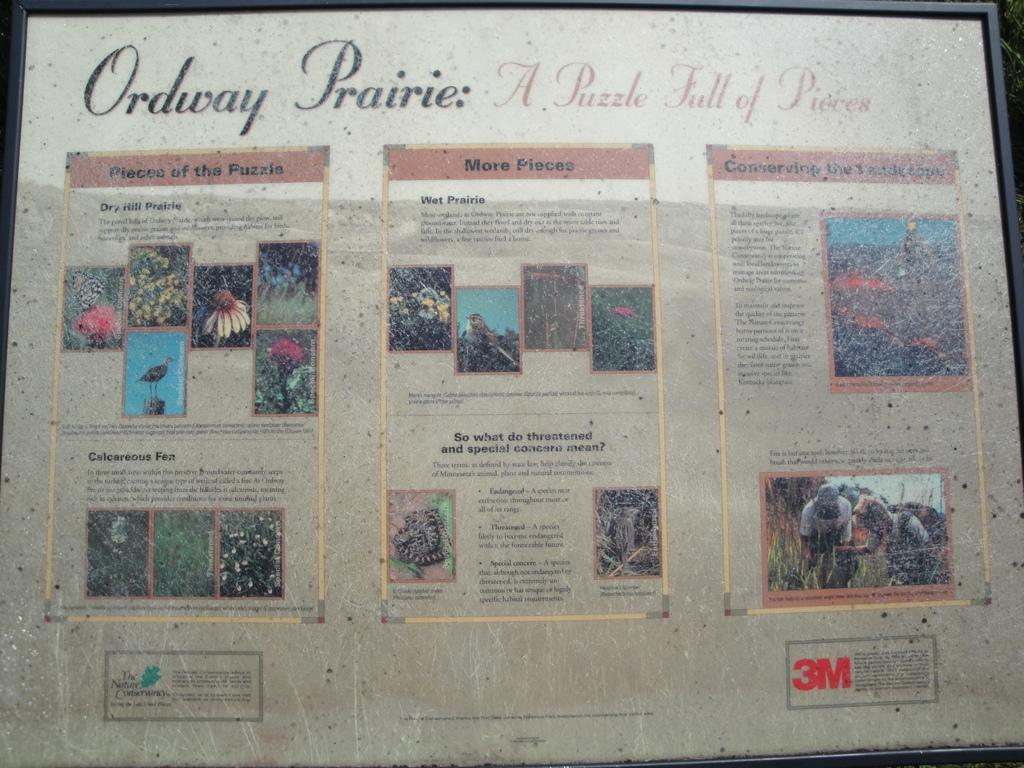<image>
Write a terse but informative summary of the picture. A poster titled Ordway Prairie: A puzzle full of pieces 